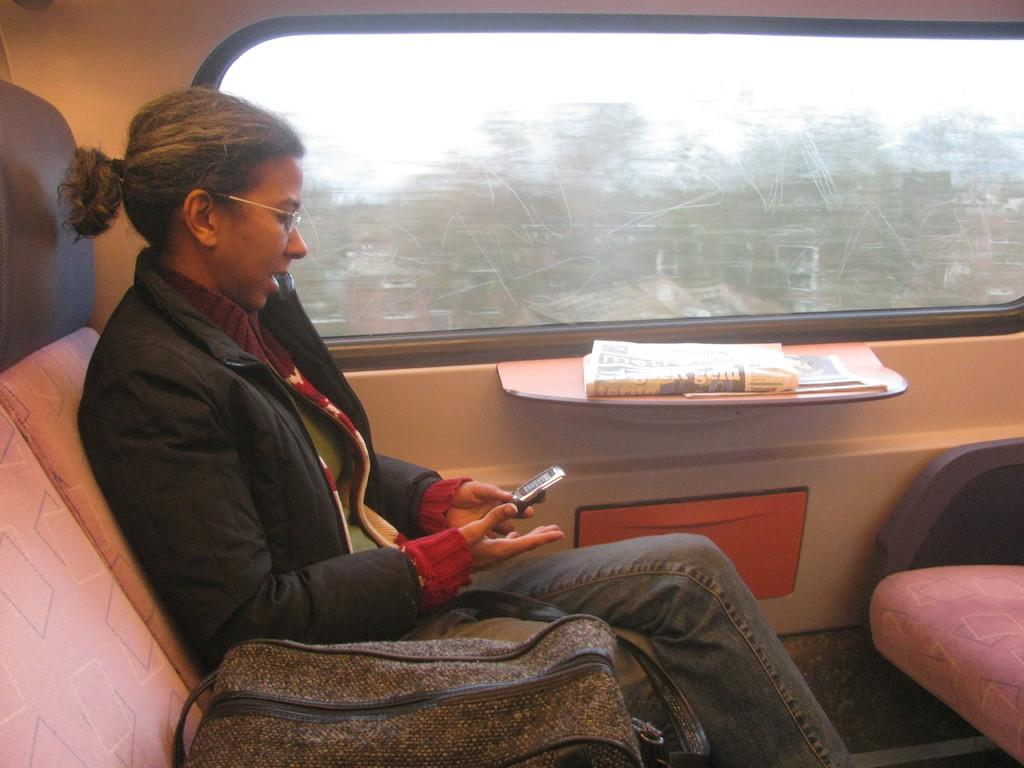Who is the main subject in the image? There is a woman in the image. What is the woman doing in the image? The woman is sitting on a seat. What object is the woman holding in the image? The woman is holding a mobile phone. What other item can be seen in the image? There is a bag in the image. What type of architectural feature is present in the image? There is a glass window in the image. What type of shoes is the hen wearing in the image? There is no hen or shoes present in the image. Who is the expert in the image? The image does not depict an expert or any expertise-related activity. 